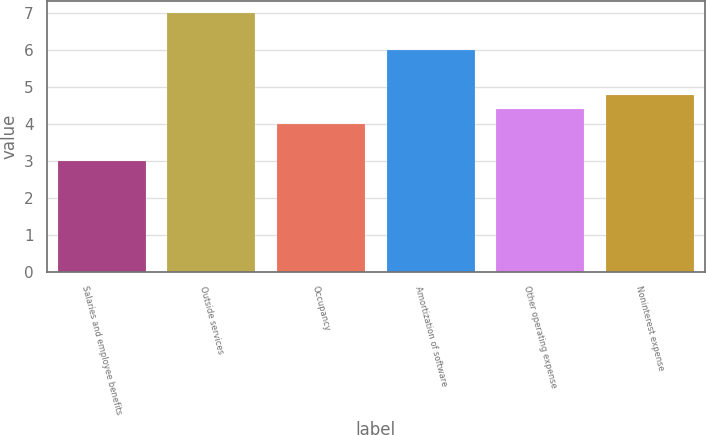Convert chart. <chart><loc_0><loc_0><loc_500><loc_500><bar_chart><fcel>Salaries and employee benefits<fcel>Outside services<fcel>Occupancy<fcel>Amortization of software<fcel>Other operating expense<fcel>Noninterest expense<nl><fcel>3<fcel>7<fcel>4<fcel>6<fcel>4.4<fcel>4.8<nl></chart> 